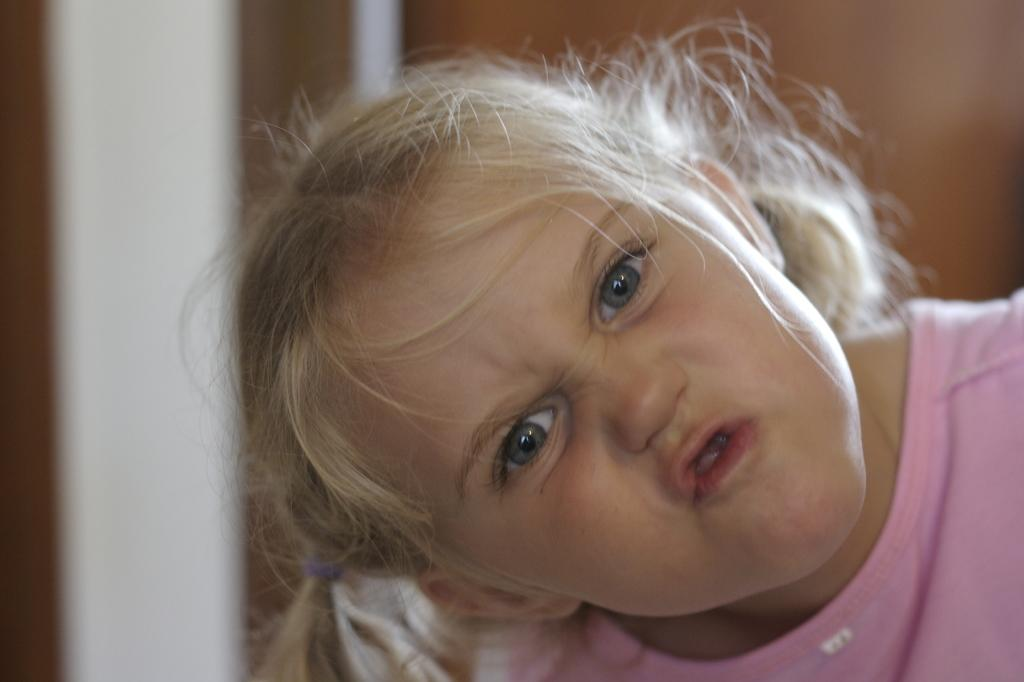Who is the main subject in the image? There is a girl in the image. Where is the girl located in the image? The girl is in the front of the image. What is the girl wearing in the image? The girl is wearing a pink t-shirt. Can you describe the background of the image? The background of the image is blurry. What type of cream is the girl using to make soda in the image? There is no cream or soda present in the image; the girl is simply wearing a pink t-shirt in the front of the image. 